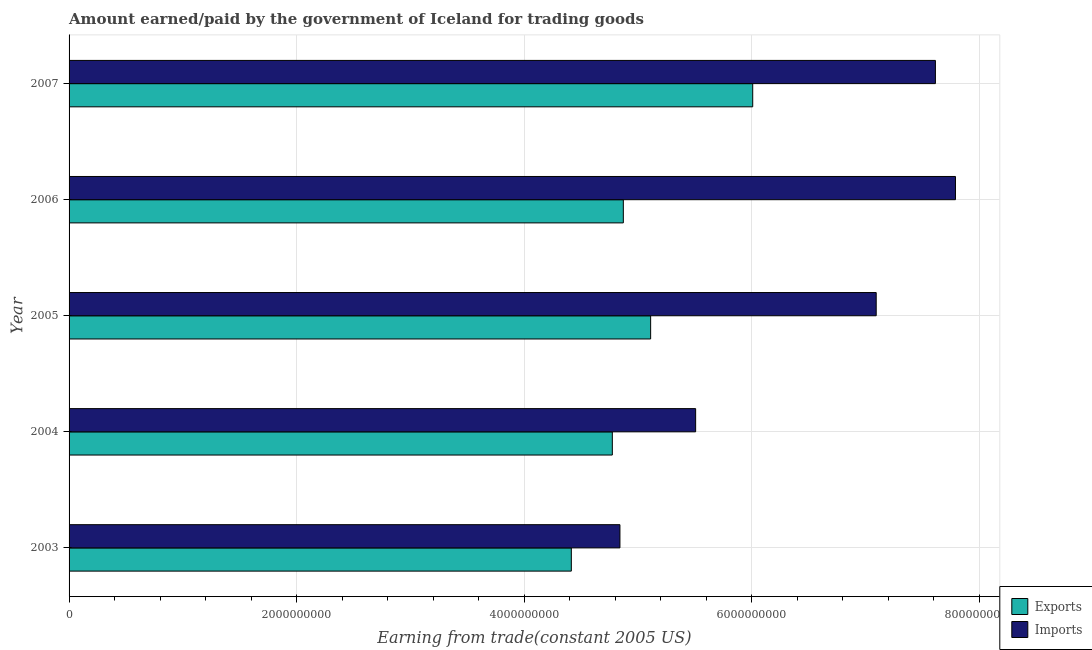How many different coloured bars are there?
Provide a short and direct response. 2. Are the number of bars per tick equal to the number of legend labels?
Offer a terse response. Yes. What is the amount earned from exports in 2006?
Offer a terse response. 4.87e+09. Across all years, what is the maximum amount paid for imports?
Ensure brevity in your answer.  7.79e+09. Across all years, what is the minimum amount earned from exports?
Offer a terse response. 4.41e+09. In which year was the amount paid for imports maximum?
Provide a short and direct response. 2006. In which year was the amount paid for imports minimum?
Give a very brief answer. 2003. What is the total amount earned from exports in the graph?
Offer a terse response. 2.52e+1. What is the difference between the amount paid for imports in 2005 and that in 2007?
Your answer should be very brief. -5.20e+08. What is the difference between the amount earned from exports in 2004 and the amount paid for imports in 2007?
Provide a succinct answer. -2.84e+09. What is the average amount earned from exports per year?
Keep it short and to the point. 5.04e+09. In the year 2007, what is the difference between the amount paid for imports and amount earned from exports?
Provide a succinct answer. 1.61e+09. In how many years, is the amount paid for imports greater than 7200000000 US$?
Offer a terse response. 2. What is the ratio of the amount paid for imports in 2003 to that in 2006?
Your answer should be compact. 0.62. Is the difference between the amount earned from exports in 2003 and 2004 greater than the difference between the amount paid for imports in 2003 and 2004?
Keep it short and to the point. Yes. What is the difference between the highest and the second highest amount earned from exports?
Your answer should be compact. 8.97e+08. What is the difference between the highest and the lowest amount earned from exports?
Offer a very short reply. 1.59e+09. In how many years, is the amount earned from exports greater than the average amount earned from exports taken over all years?
Your response must be concise. 2. What does the 1st bar from the top in 2003 represents?
Offer a very short reply. Imports. What does the 2nd bar from the bottom in 2006 represents?
Ensure brevity in your answer.  Imports. How many bars are there?
Make the answer very short. 10. Does the graph contain any zero values?
Provide a succinct answer. No. What is the title of the graph?
Offer a terse response. Amount earned/paid by the government of Iceland for trading goods. Does "Borrowers" appear as one of the legend labels in the graph?
Make the answer very short. No. What is the label or title of the X-axis?
Your answer should be compact. Earning from trade(constant 2005 US). What is the label or title of the Y-axis?
Ensure brevity in your answer.  Year. What is the Earning from trade(constant 2005 US) of Exports in 2003?
Provide a succinct answer. 4.41e+09. What is the Earning from trade(constant 2005 US) in Imports in 2003?
Provide a succinct answer. 4.84e+09. What is the Earning from trade(constant 2005 US) of Exports in 2004?
Your response must be concise. 4.77e+09. What is the Earning from trade(constant 2005 US) of Imports in 2004?
Make the answer very short. 5.51e+09. What is the Earning from trade(constant 2005 US) of Exports in 2005?
Provide a short and direct response. 5.11e+09. What is the Earning from trade(constant 2005 US) in Imports in 2005?
Provide a short and direct response. 7.09e+09. What is the Earning from trade(constant 2005 US) in Exports in 2006?
Offer a very short reply. 4.87e+09. What is the Earning from trade(constant 2005 US) in Imports in 2006?
Your answer should be compact. 7.79e+09. What is the Earning from trade(constant 2005 US) of Exports in 2007?
Provide a short and direct response. 6.01e+09. What is the Earning from trade(constant 2005 US) in Imports in 2007?
Offer a very short reply. 7.61e+09. Across all years, what is the maximum Earning from trade(constant 2005 US) of Exports?
Your answer should be very brief. 6.01e+09. Across all years, what is the maximum Earning from trade(constant 2005 US) in Imports?
Your answer should be very brief. 7.79e+09. Across all years, what is the minimum Earning from trade(constant 2005 US) in Exports?
Offer a terse response. 4.41e+09. Across all years, what is the minimum Earning from trade(constant 2005 US) in Imports?
Provide a short and direct response. 4.84e+09. What is the total Earning from trade(constant 2005 US) in Exports in the graph?
Your response must be concise. 2.52e+1. What is the total Earning from trade(constant 2005 US) in Imports in the graph?
Provide a succinct answer. 3.28e+1. What is the difference between the Earning from trade(constant 2005 US) in Exports in 2003 and that in 2004?
Give a very brief answer. -3.60e+08. What is the difference between the Earning from trade(constant 2005 US) in Imports in 2003 and that in 2004?
Keep it short and to the point. -6.65e+08. What is the difference between the Earning from trade(constant 2005 US) in Exports in 2003 and that in 2005?
Keep it short and to the point. -6.97e+08. What is the difference between the Earning from trade(constant 2005 US) in Imports in 2003 and that in 2005?
Give a very brief answer. -2.25e+09. What is the difference between the Earning from trade(constant 2005 US) in Exports in 2003 and that in 2006?
Your answer should be compact. -4.57e+08. What is the difference between the Earning from trade(constant 2005 US) of Imports in 2003 and that in 2006?
Your response must be concise. -2.95e+09. What is the difference between the Earning from trade(constant 2005 US) of Exports in 2003 and that in 2007?
Provide a succinct answer. -1.59e+09. What is the difference between the Earning from trade(constant 2005 US) in Imports in 2003 and that in 2007?
Make the answer very short. -2.77e+09. What is the difference between the Earning from trade(constant 2005 US) in Exports in 2004 and that in 2005?
Give a very brief answer. -3.37e+08. What is the difference between the Earning from trade(constant 2005 US) of Imports in 2004 and that in 2005?
Ensure brevity in your answer.  -1.59e+09. What is the difference between the Earning from trade(constant 2005 US) in Exports in 2004 and that in 2006?
Provide a short and direct response. -9.66e+07. What is the difference between the Earning from trade(constant 2005 US) in Imports in 2004 and that in 2006?
Make the answer very short. -2.28e+09. What is the difference between the Earning from trade(constant 2005 US) in Exports in 2004 and that in 2007?
Ensure brevity in your answer.  -1.23e+09. What is the difference between the Earning from trade(constant 2005 US) in Imports in 2004 and that in 2007?
Keep it short and to the point. -2.11e+09. What is the difference between the Earning from trade(constant 2005 US) in Exports in 2005 and that in 2006?
Your response must be concise. 2.40e+08. What is the difference between the Earning from trade(constant 2005 US) of Imports in 2005 and that in 2006?
Ensure brevity in your answer.  -6.97e+08. What is the difference between the Earning from trade(constant 2005 US) in Exports in 2005 and that in 2007?
Ensure brevity in your answer.  -8.97e+08. What is the difference between the Earning from trade(constant 2005 US) of Imports in 2005 and that in 2007?
Provide a succinct answer. -5.20e+08. What is the difference between the Earning from trade(constant 2005 US) in Exports in 2006 and that in 2007?
Offer a very short reply. -1.14e+09. What is the difference between the Earning from trade(constant 2005 US) of Imports in 2006 and that in 2007?
Your response must be concise. 1.76e+08. What is the difference between the Earning from trade(constant 2005 US) of Exports in 2003 and the Earning from trade(constant 2005 US) of Imports in 2004?
Make the answer very short. -1.09e+09. What is the difference between the Earning from trade(constant 2005 US) of Exports in 2003 and the Earning from trade(constant 2005 US) of Imports in 2005?
Your answer should be very brief. -2.68e+09. What is the difference between the Earning from trade(constant 2005 US) of Exports in 2003 and the Earning from trade(constant 2005 US) of Imports in 2006?
Your answer should be very brief. -3.38e+09. What is the difference between the Earning from trade(constant 2005 US) in Exports in 2003 and the Earning from trade(constant 2005 US) in Imports in 2007?
Give a very brief answer. -3.20e+09. What is the difference between the Earning from trade(constant 2005 US) of Exports in 2004 and the Earning from trade(constant 2005 US) of Imports in 2005?
Keep it short and to the point. -2.32e+09. What is the difference between the Earning from trade(constant 2005 US) in Exports in 2004 and the Earning from trade(constant 2005 US) in Imports in 2006?
Offer a terse response. -3.02e+09. What is the difference between the Earning from trade(constant 2005 US) in Exports in 2004 and the Earning from trade(constant 2005 US) in Imports in 2007?
Make the answer very short. -2.84e+09. What is the difference between the Earning from trade(constant 2005 US) in Exports in 2005 and the Earning from trade(constant 2005 US) in Imports in 2006?
Provide a succinct answer. -2.68e+09. What is the difference between the Earning from trade(constant 2005 US) in Exports in 2005 and the Earning from trade(constant 2005 US) in Imports in 2007?
Give a very brief answer. -2.50e+09. What is the difference between the Earning from trade(constant 2005 US) of Exports in 2006 and the Earning from trade(constant 2005 US) of Imports in 2007?
Provide a succinct answer. -2.74e+09. What is the average Earning from trade(constant 2005 US) of Exports per year?
Ensure brevity in your answer.  5.04e+09. What is the average Earning from trade(constant 2005 US) of Imports per year?
Your answer should be very brief. 6.57e+09. In the year 2003, what is the difference between the Earning from trade(constant 2005 US) of Exports and Earning from trade(constant 2005 US) of Imports?
Make the answer very short. -4.27e+08. In the year 2004, what is the difference between the Earning from trade(constant 2005 US) of Exports and Earning from trade(constant 2005 US) of Imports?
Provide a succinct answer. -7.32e+08. In the year 2005, what is the difference between the Earning from trade(constant 2005 US) in Exports and Earning from trade(constant 2005 US) in Imports?
Your answer should be compact. -1.98e+09. In the year 2006, what is the difference between the Earning from trade(constant 2005 US) of Exports and Earning from trade(constant 2005 US) of Imports?
Provide a succinct answer. -2.92e+09. In the year 2007, what is the difference between the Earning from trade(constant 2005 US) of Exports and Earning from trade(constant 2005 US) of Imports?
Provide a succinct answer. -1.61e+09. What is the ratio of the Earning from trade(constant 2005 US) of Exports in 2003 to that in 2004?
Ensure brevity in your answer.  0.92. What is the ratio of the Earning from trade(constant 2005 US) in Imports in 2003 to that in 2004?
Offer a terse response. 0.88. What is the ratio of the Earning from trade(constant 2005 US) of Exports in 2003 to that in 2005?
Offer a terse response. 0.86. What is the ratio of the Earning from trade(constant 2005 US) of Imports in 2003 to that in 2005?
Your response must be concise. 0.68. What is the ratio of the Earning from trade(constant 2005 US) in Exports in 2003 to that in 2006?
Provide a short and direct response. 0.91. What is the ratio of the Earning from trade(constant 2005 US) in Imports in 2003 to that in 2006?
Your response must be concise. 0.62. What is the ratio of the Earning from trade(constant 2005 US) in Exports in 2003 to that in 2007?
Ensure brevity in your answer.  0.73. What is the ratio of the Earning from trade(constant 2005 US) in Imports in 2003 to that in 2007?
Make the answer very short. 0.64. What is the ratio of the Earning from trade(constant 2005 US) of Exports in 2004 to that in 2005?
Offer a terse response. 0.93. What is the ratio of the Earning from trade(constant 2005 US) of Imports in 2004 to that in 2005?
Keep it short and to the point. 0.78. What is the ratio of the Earning from trade(constant 2005 US) of Exports in 2004 to that in 2006?
Give a very brief answer. 0.98. What is the ratio of the Earning from trade(constant 2005 US) in Imports in 2004 to that in 2006?
Make the answer very short. 0.71. What is the ratio of the Earning from trade(constant 2005 US) in Exports in 2004 to that in 2007?
Offer a terse response. 0.79. What is the ratio of the Earning from trade(constant 2005 US) of Imports in 2004 to that in 2007?
Offer a terse response. 0.72. What is the ratio of the Earning from trade(constant 2005 US) of Exports in 2005 to that in 2006?
Offer a terse response. 1.05. What is the ratio of the Earning from trade(constant 2005 US) in Imports in 2005 to that in 2006?
Your answer should be compact. 0.91. What is the ratio of the Earning from trade(constant 2005 US) of Exports in 2005 to that in 2007?
Offer a terse response. 0.85. What is the ratio of the Earning from trade(constant 2005 US) in Imports in 2005 to that in 2007?
Your answer should be very brief. 0.93. What is the ratio of the Earning from trade(constant 2005 US) in Exports in 2006 to that in 2007?
Offer a terse response. 0.81. What is the ratio of the Earning from trade(constant 2005 US) in Imports in 2006 to that in 2007?
Your response must be concise. 1.02. What is the difference between the highest and the second highest Earning from trade(constant 2005 US) in Exports?
Offer a terse response. 8.97e+08. What is the difference between the highest and the second highest Earning from trade(constant 2005 US) in Imports?
Ensure brevity in your answer.  1.76e+08. What is the difference between the highest and the lowest Earning from trade(constant 2005 US) in Exports?
Provide a succinct answer. 1.59e+09. What is the difference between the highest and the lowest Earning from trade(constant 2005 US) of Imports?
Ensure brevity in your answer.  2.95e+09. 